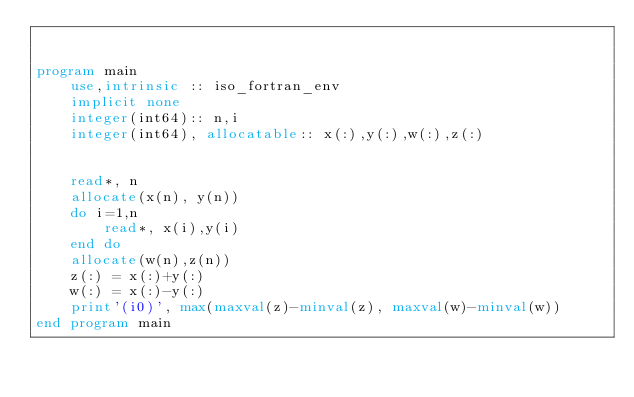<code> <loc_0><loc_0><loc_500><loc_500><_FORTRAN_>

program main
    use,intrinsic :: iso_fortran_env
    implicit none
    integer(int64):: n,i
    integer(int64), allocatable:: x(:),y(:),w(:),z(:)


    read*, n
    allocate(x(n), y(n))
    do i=1,n
        read*, x(i),y(i)
    end do
    allocate(w(n),z(n))
    z(:) = x(:)+y(:)
    w(:) = x(:)-y(:)
    print'(i0)', max(maxval(z)-minval(z), maxval(w)-minval(w))
end program main</code> 